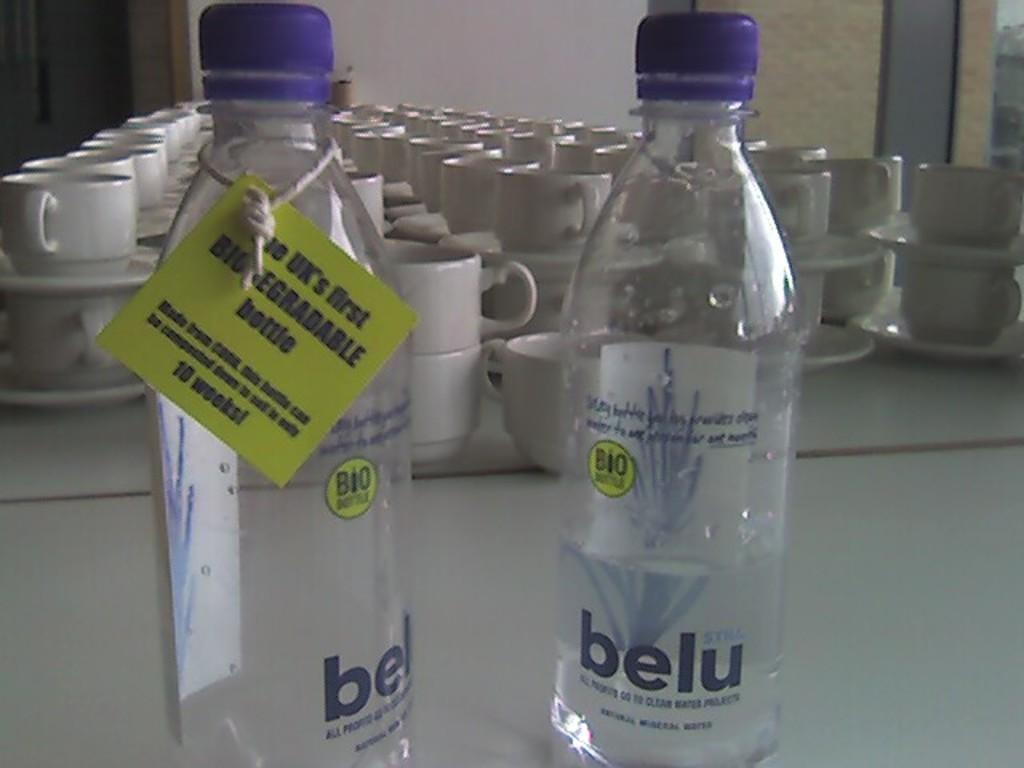<image>
Offer a succinct explanation of the picture presented. two Belu water bottles that are the UK's first Biodegradable bottles. 